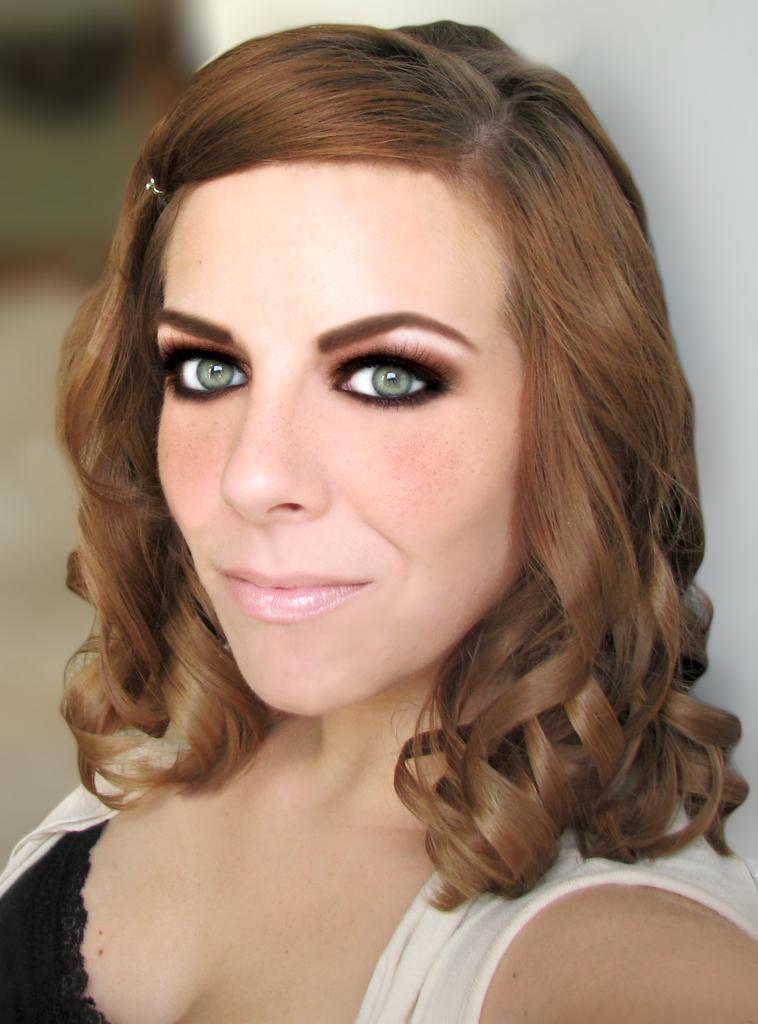Can you describe this image briefly? There is a woman in white color jacket, smiling. In the background, there is white wall. 